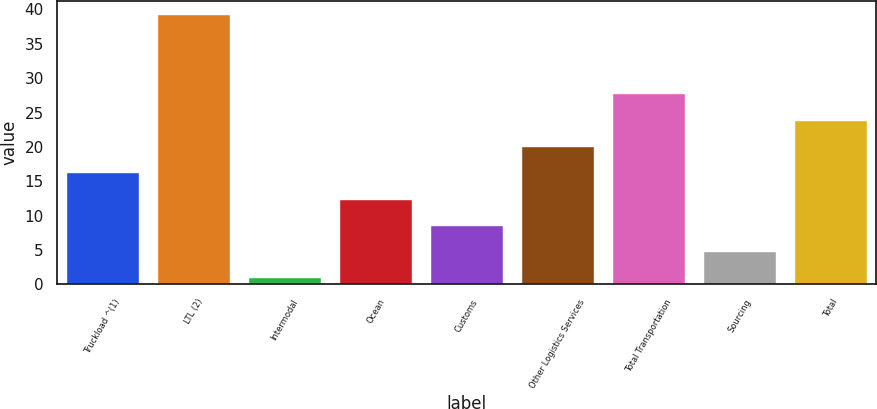<chart> <loc_0><loc_0><loc_500><loc_500><bar_chart><fcel>Truckload ^(1)<fcel>LTL (2)<fcel>Intermodal<fcel>Ocean<fcel>Customs<fcel>Other Logistics Services<fcel>Total Transportation<fcel>Sourcing<fcel>Total<nl><fcel>16.32<fcel>39.3<fcel>1<fcel>12.49<fcel>8.66<fcel>20.15<fcel>27.81<fcel>4.83<fcel>23.98<nl></chart> 